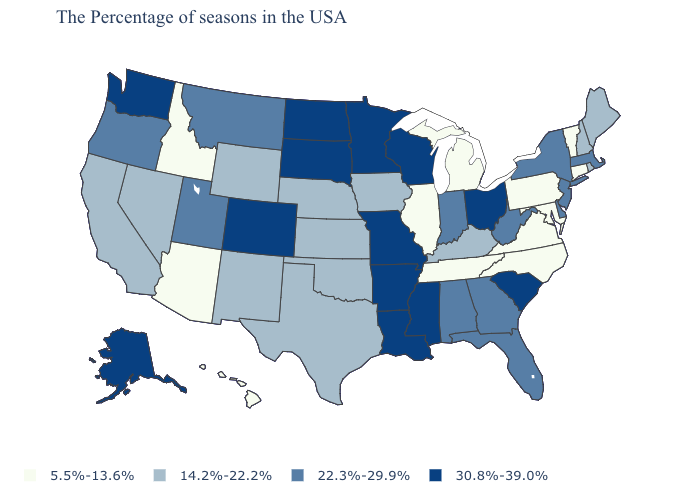Does California have the highest value in the USA?
Write a very short answer. No. Does Connecticut have the lowest value in the USA?
Write a very short answer. Yes. Does the first symbol in the legend represent the smallest category?
Write a very short answer. Yes. Name the states that have a value in the range 5.5%-13.6%?
Answer briefly. Vermont, Connecticut, Maryland, Pennsylvania, Virginia, North Carolina, Michigan, Tennessee, Illinois, Arizona, Idaho, Hawaii. What is the value of Hawaii?
Give a very brief answer. 5.5%-13.6%. Name the states that have a value in the range 14.2%-22.2%?
Quick response, please. Maine, Rhode Island, New Hampshire, Kentucky, Iowa, Kansas, Nebraska, Oklahoma, Texas, Wyoming, New Mexico, Nevada, California. Which states have the lowest value in the Northeast?
Write a very short answer. Vermont, Connecticut, Pennsylvania. What is the value of Washington?
Quick response, please. 30.8%-39.0%. Which states have the highest value in the USA?
Short answer required. South Carolina, Ohio, Wisconsin, Mississippi, Louisiana, Missouri, Arkansas, Minnesota, South Dakota, North Dakota, Colorado, Washington, Alaska. Name the states that have a value in the range 30.8%-39.0%?
Short answer required. South Carolina, Ohio, Wisconsin, Mississippi, Louisiana, Missouri, Arkansas, Minnesota, South Dakota, North Dakota, Colorado, Washington, Alaska. What is the highest value in states that border Pennsylvania?
Concise answer only. 30.8%-39.0%. Does New York have the same value as Georgia?
Write a very short answer. Yes. Which states have the highest value in the USA?
Quick response, please. South Carolina, Ohio, Wisconsin, Mississippi, Louisiana, Missouri, Arkansas, Minnesota, South Dakota, North Dakota, Colorado, Washington, Alaska. Among the states that border Nebraska , which have the highest value?
Keep it brief. Missouri, South Dakota, Colorado. What is the value of Louisiana?
Concise answer only. 30.8%-39.0%. 